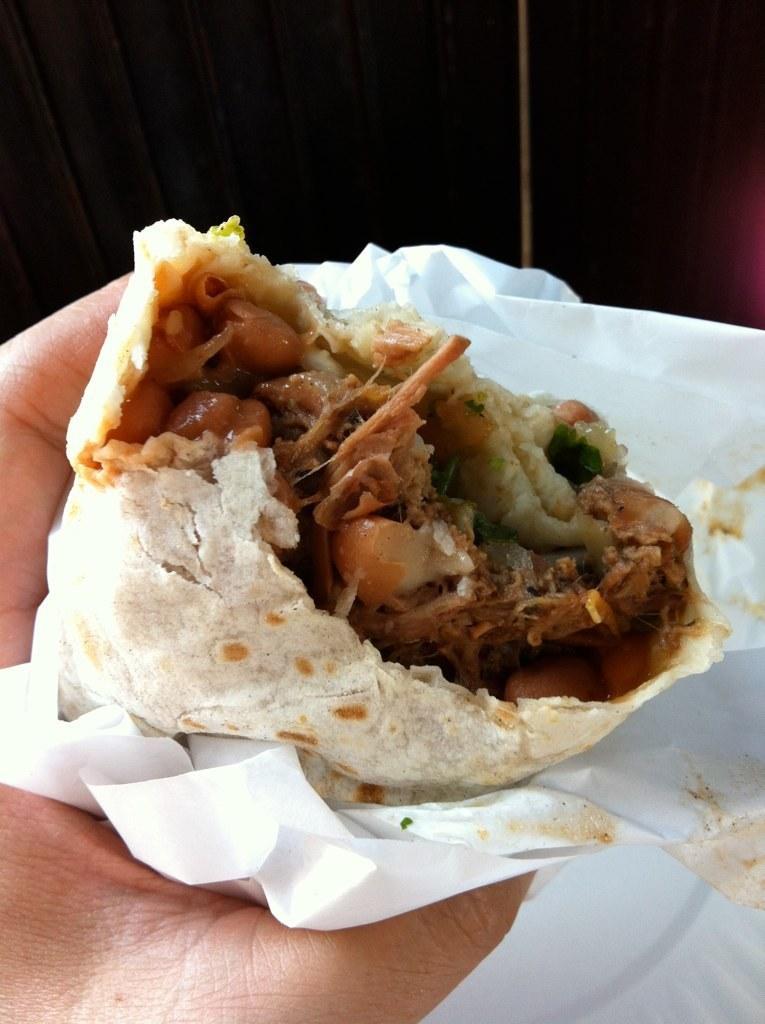Please provide a concise description of this image. In this image we can see a person holding some food with a tissue paper. 